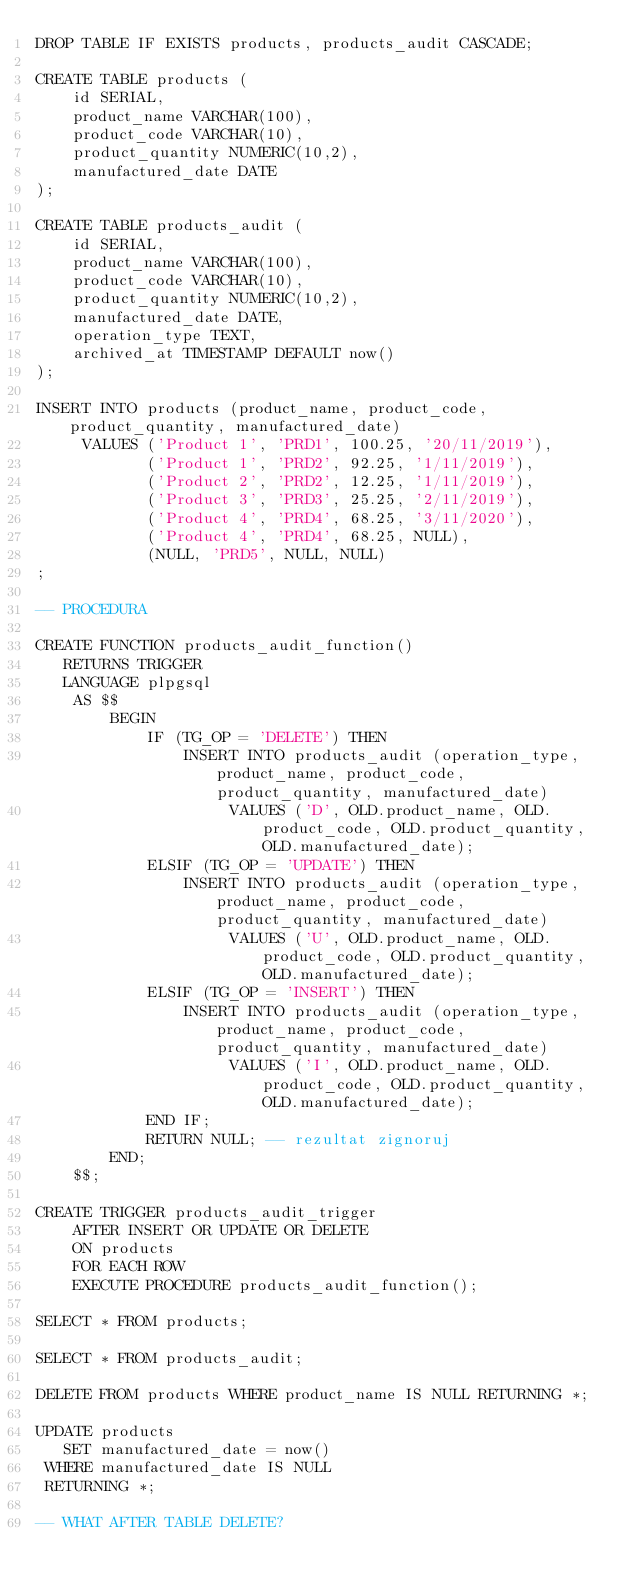Convert code to text. <code><loc_0><loc_0><loc_500><loc_500><_SQL_>DROP TABLE IF EXISTS products, products_audit CASCADE;

CREATE TABLE products (
	id SERIAL,
	product_name VARCHAR(100),
	product_code VARCHAR(10),
	product_quantity NUMERIC(10,2),
	manufactured_date DATE
);

CREATE TABLE products_audit (
	id SERIAL,
	product_name VARCHAR(100),
	product_code VARCHAR(10),
	product_quantity NUMERIC(10,2),
	manufactured_date DATE,
	operation_type TEXT,
	archived_at TIMESTAMP DEFAULT now()
);

INSERT INTO products (product_name, product_code, product_quantity, manufactured_date)
 	 VALUES ('Product 1', 'PRD1', 100.25, '20/11/2019'),
 	 		('Product 1', 'PRD2', 92.25, '1/11/2019'),
 	 		('Product 2', 'PRD2', 12.25, '1/11/2019'),
 	 		('Product 3', 'PRD3', 25.25, '2/11/2019'),
 	 		('Product 4', 'PRD4', 68.25, '3/11/2020'),
 	 		('Product 4', 'PRD4', 68.25, NULL),
            (NULL, 'PRD5', NULL, NULL)
;

-- PROCEDURA

CREATE FUNCTION products_audit_function() 
   RETURNS TRIGGER 
   LANGUAGE plpgsql
	AS $$
		BEGIN
	        IF (TG_OP = 'DELETE') THEN
	            INSERT INTO products_audit (operation_type, product_name, product_code, product_quantity, manufactured_date)
	                 VALUES ('D', OLD.product_name, OLD.product_code, OLD.product_quantity, OLD.manufactured_date);
	        ELSIF (TG_OP = 'UPDATE') THEN
	            INSERT INTO products_audit (operation_type, product_name, product_code, product_quantity, manufactured_date)
	                 VALUES ('U', OLD.product_name, OLD.product_code, OLD.product_quantity, OLD.manufactured_date);
	        ELSIF (TG_OP = 'INSERT') THEN
	            INSERT INTO products_audit (operation_type, product_name, product_code, product_quantity, manufactured_date)
	                 VALUES ('I', OLD.product_name, OLD.product_code, OLD.product_quantity, OLD.manufactured_date);
	        END IF;
	        RETURN NULL; -- rezultat zignoruj
		END;
	$$;
		
CREATE TRIGGER products_audit_trigger 
	AFTER INSERT OR UPDATE OR DELETE
   	ON products
	FOR EACH ROW 
    EXECUTE PROCEDURE products_audit_function();
   
SELECT * FROM products;

SELECT * FROM products_audit;

DELETE FROM products WHERE product_name IS NULL RETURNING *;

UPDATE products 
   SET manufactured_date = now() 
 WHERE manufactured_date IS NULL 
 RETURNING *;

-- WHAT AFTER TABLE DELETE? </code> 